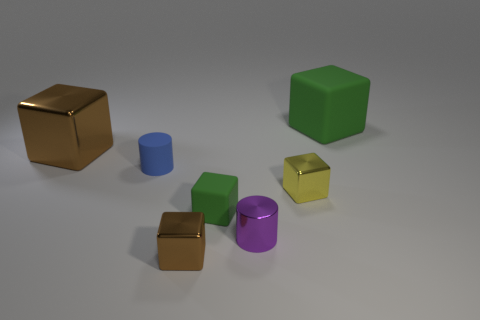Subtract all small brown metallic cubes. How many cubes are left? 4 Subtract all yellow blocks. How many blocks are left? 4 Subtract all purple cubes. Subtract all gray spheres. How many cubes are left? 5 Add 1 green rubber spheres. How many objects exist? 8 Subtract all blocks. How many objects are left? 2 Add 4 cubes. How many cubes are left? 9 Add 4 tiny purple metallic things. How many tiny purple metallic things exist? 5 Subtract 0 cyan balls. How many objects are left? 7 Subtract all green matte blocks. Subtract all small brown cubes. How many objects are left? 4 